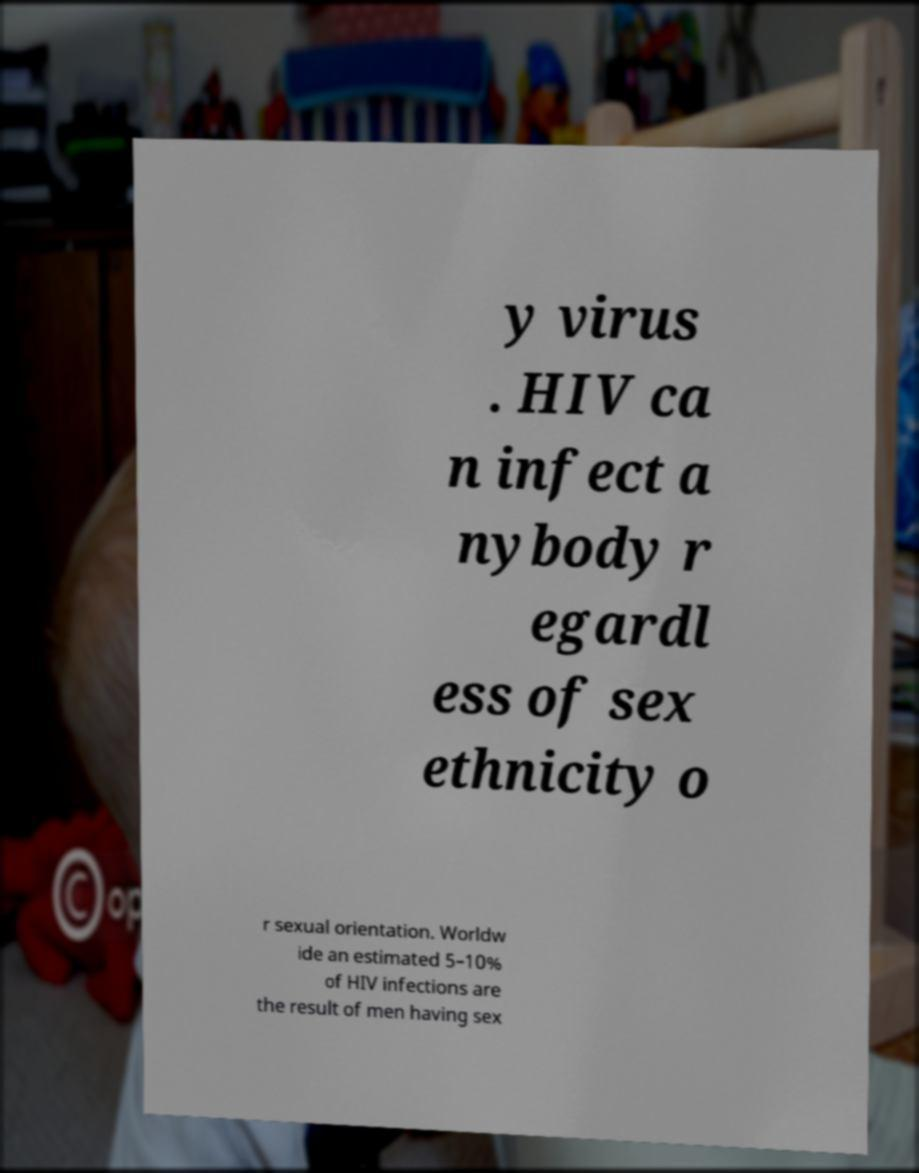There's text embedded in this image that I need extracted. Can you transcribe it verbatim? y virus . HIV ca n infect a nybody r egardl ess of sex ethnicity o r sexual orientation. Worldw ide an estimated 5–10% of HIV infections are the result of men having sex 